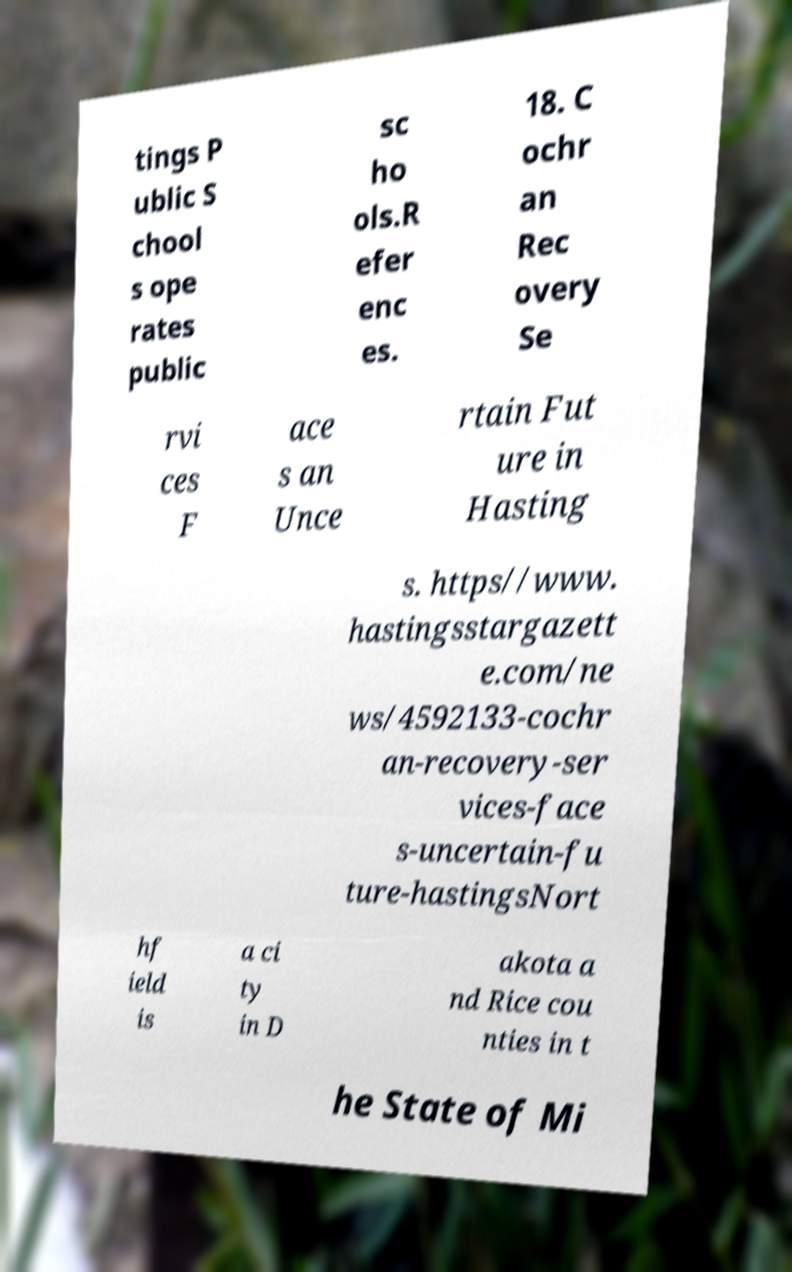For documentation purposes, I need the text within this image transcribed. Could you provide that? tings P ublic S chool s ope rates public sc ho ols.R efer enc es. 18. C ochr an Rec overy Se rvi ces F ace s an Unce rtain Fut ure in Hasting s. https//www. hastingsstargazett e.com/ne ws/4592133-cochr an-recovery-ser vices-face s-uncertain-fu ture-hastingsNort hf ield is a ci ty in D akota a nd Rice cou nties in t he State of Mi 